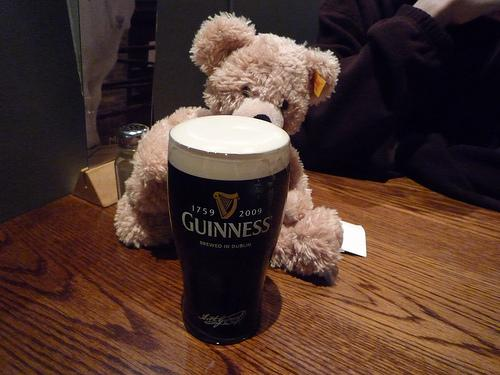Explain how the beer glass appears and its position in relation to the table. The beer glass is sitting on an oak table and has its shadow cast underneath it. Provide a detailed description of the objects placed on the table. There is a tan teddy bear with an orange tag on its ear and a Guinness beer in a tall glass, alongside a silver-topped glass pepper shaker and a gold menu holder with a menu. In terms of the teddy bear, mention what is noticeable about its ear and ocation. The teddy bear has a tan ribbon in its ear and is sitting behind the beer glass. How many bears can you find in the image, and what is unique about each one? There is one teddy bear, which is tan-colored and has an orange tag and a tan ribbon in its ear. Identify the type of drink in the glass and its color. The drink is a Guinness beer, and it is black in color. Identify the two primary objects in the foreground of the image. The beer mug and the tan teddy bear are the primary objects in the foreground. What type of surfaces is displayed in the image and what material is it made of? There is a wooden table made out of oak in the image. Examine the interaction between the teddy bear and the beer glass. The teddy bear is sitting behind the beer glass, partially hidden by it. Describe the sentiment or atmosphere captured in the image. The image has a warm, cozy atmosphere with a teddy bear and pint of beer on a wooden table. Determine if there is a person in the image, and if so, describe their attire. There is a person in the background wearing a sweater. 